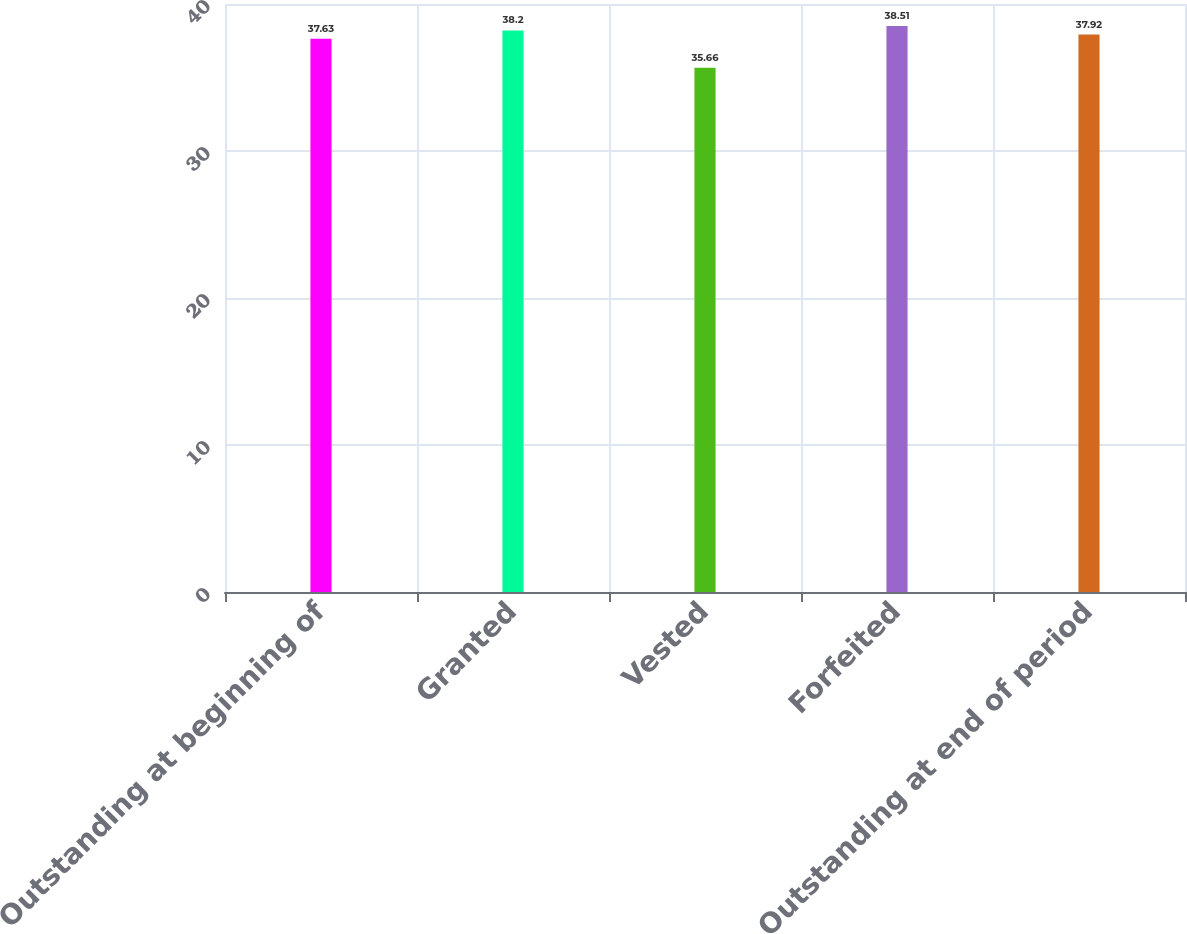Convert chart to OTSL. <chart><loc_0><loc_0><loc_500><loc_500><bar_chart><fcel>Outstanding at beginning of<fcel>Granted<fcel>Vested<fcel>Forfeited<fcel>Outstanding at end of period<nl><fcel>37.63<fcel>38.2<fcel>35.66<fcel>38.51<fcel>37.92<nl></chart> 